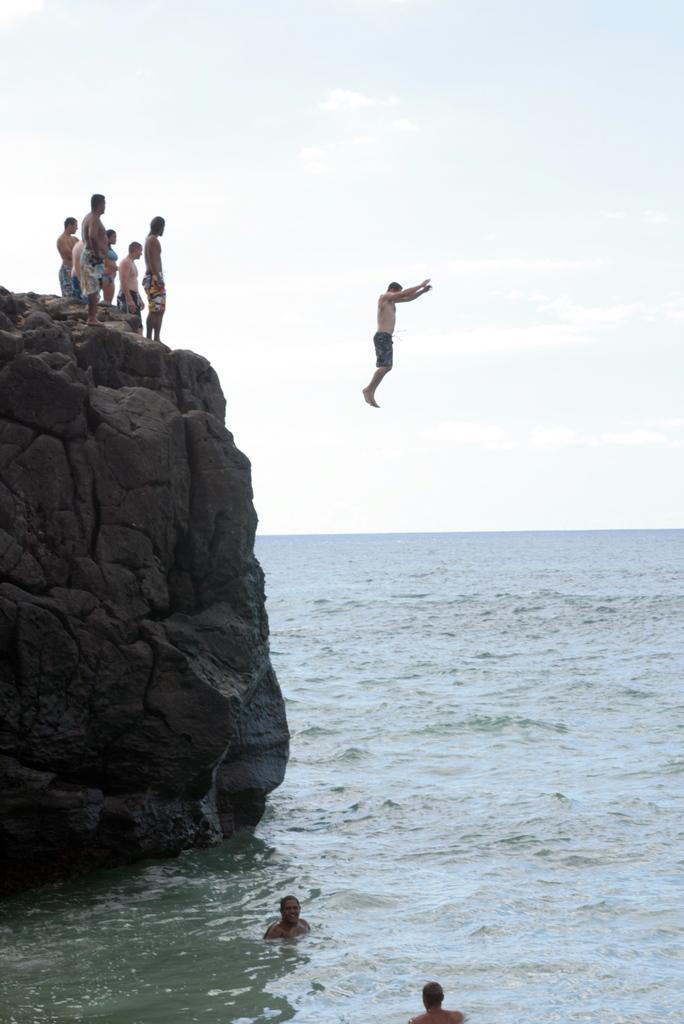Could you give a brief overview of what you see in this image? In this image we can see a group of people standing on the rock, a person is jumping, two people are swimming in the water and the sky in the background. 